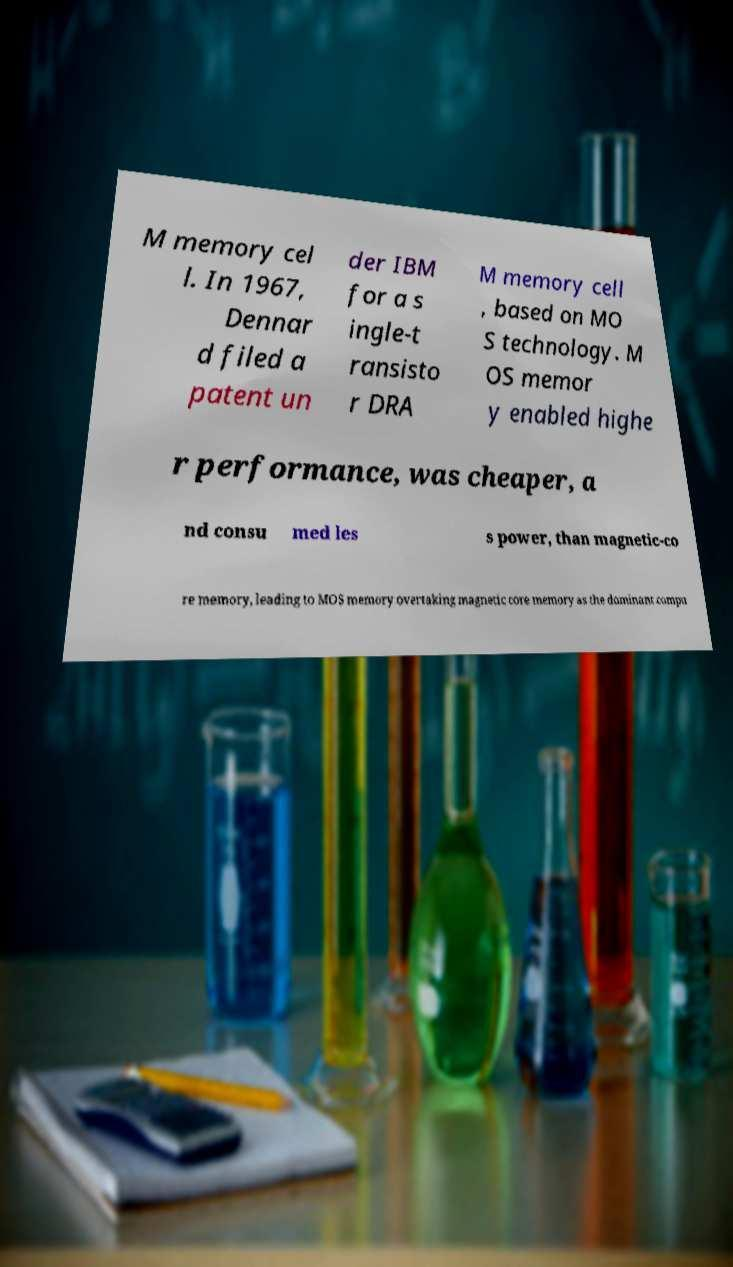Could you assist in decoding the text presented in this image and type it out clearly? M memory cel l. In 1967, Dennar d filed a patent un der IBM for a s ingle-t ransisto r DRA M memory cell , based on MO S technology. M OS memor y enabled highe r performance, was cheaper, a nd consu med les s power, than magnetic-co re memory, leading to MOS memory overtaking magnetic core memory as the dominant compu 